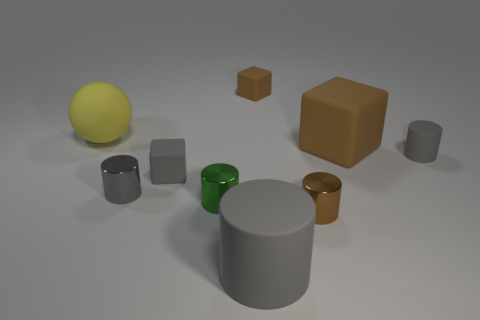What is the color of the tiny rubber cylinder?
Ensure brevity in your answer.  Gray. There is a rubber cylinder that is on the left side of the large brown rubber thing; is its size the same as the thing behind the large yellow matte object?
Ensure brevity in your answer.  No. Is the number of yellow things less than the number of blocks?
Offer a terse response. Yes. What number of gray matte things are behind the large cylinder?
Give a very brief answer. 2. What is the material of the yellow thing?
Ensure brevity in your answer.  Rubber. Does the sphere have the same color as the large matte cube?
Provide a succinct answer. No. Is the number of small rubber cubes behind the large brown matte object less than the number of yellow rubber spheres?
Your answer should be compact. No. There is a matte thing that is on the right side of the big cube; what color is it?
Offer a very short reply. Gray. What shape is the yellow object?
Your answer should be compact. Sphere. Is there a shiny thing behind the tiny rubber object to the right of the matte thing that is behind the large yellow rubber sphere?
Ensure brevity in your answer.  No. 